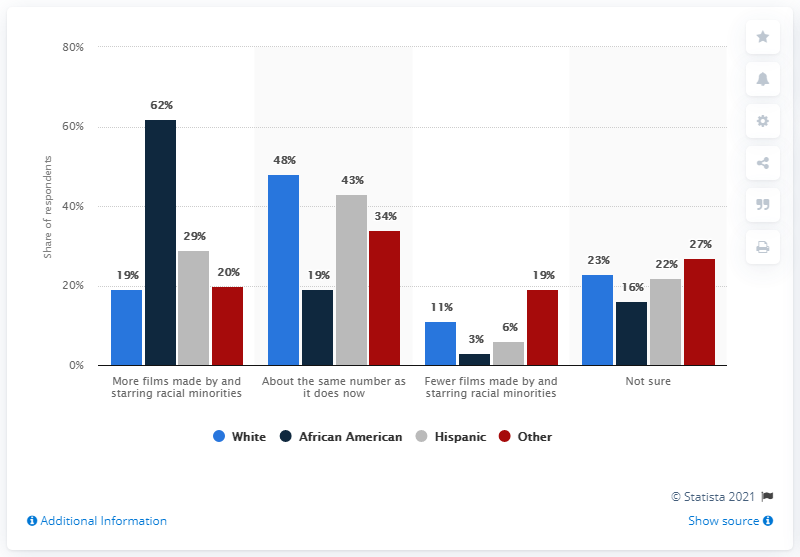Indicate a few pertinent items in this graphic. Four ethnicities have been considered. According to a recent survey, 88% of respondents were unsure about the answer. According to the survey, 29% of Hispanic respondents expressed a desire for Hollywood to produce more films made by and starring racial minorities. 